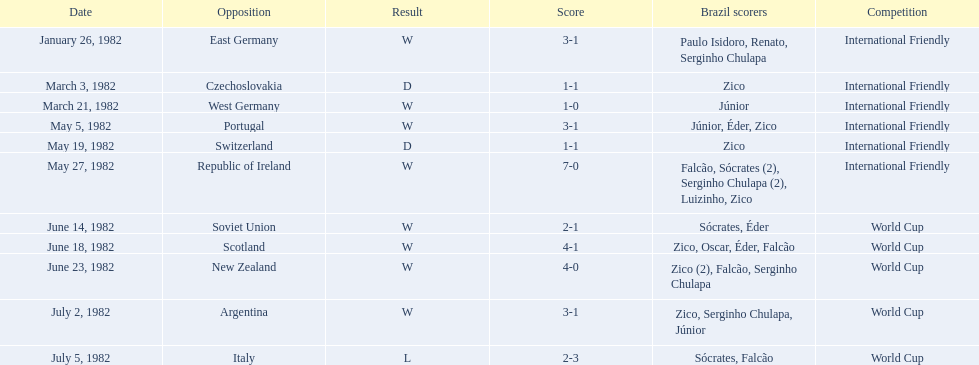What was the total number of games this team played in 1982? 11. 